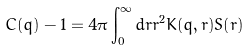Convert formula to latex. <formula><loc_0><loc_0><loc_500><loc_500>C ( q ) - 1 = 4 \pi \int _ { 0 } ^ { \infty } d r r ^ { 2 } K ( q , r ) S ( r )</formula> 